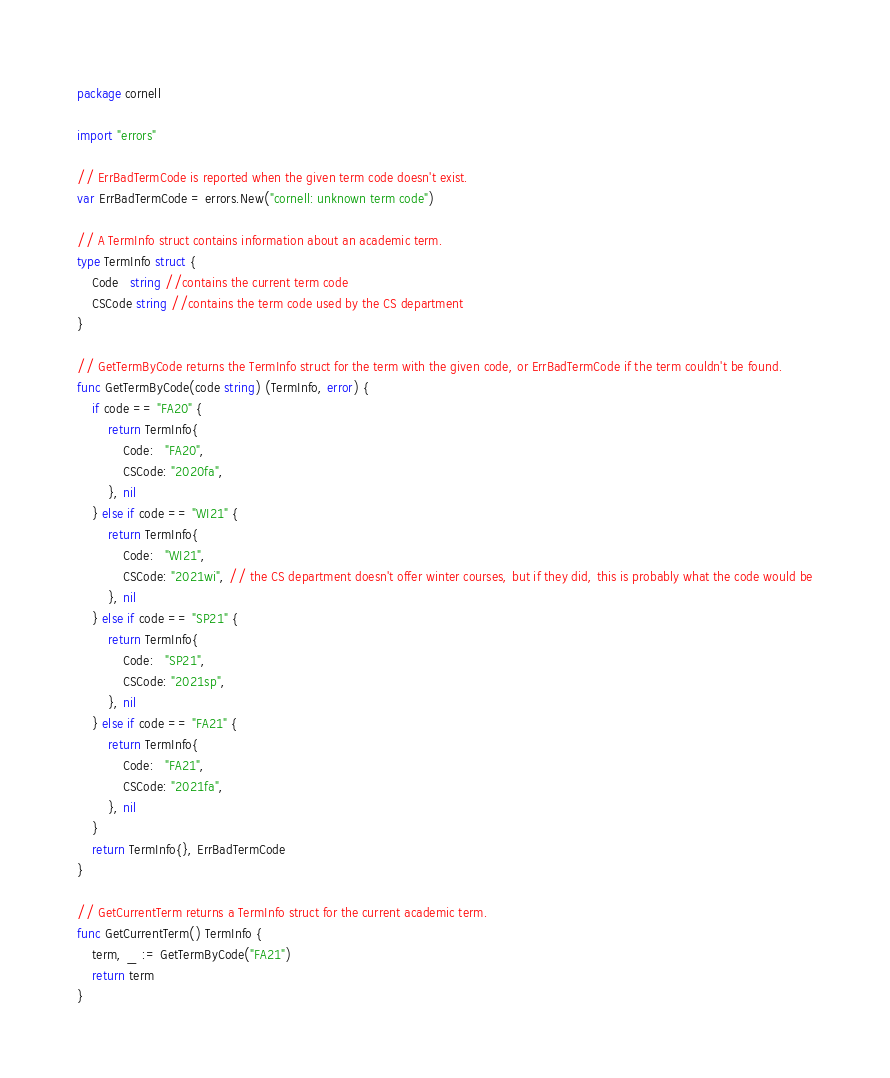<code> <loc_0><loc_0><loc_500><loc_500><_Go_>package cornell

import "errors"

// ErrBadTermCode is reported when the given term code doesn't exist.
var ErrBadTermCode = errors.New("cornell: unknown term code")

// A TermInfo struct contains information about an academic term.
type TermInfo struct {
	Code   string //contains the current term code
	CSCode string //contains the term code used by the CS department
}

// GetTermByCode returns the TermInfo struct for the term with the given code, or ErrBadTermCode if the term couldn't be found.
func GetTermByCode(code string) (TermInfo, error) {
	if code == "FA20" {
		return TermInfo{
			Code:   "FA20",
			CSCode: "2020fa",
		}, nil
	} else if code == "WI21" {
		return TermInfo{
			Code:   "WI21",
			CSCode: "2021wi", // the CS department doesn't offer winter courses, but if they did, this is probably what the code would be
		}, nil
	} else if code == "SP21" {
		return TermInfo{
			Code:   "SP21",
			CSCode: "2021sp",
		}, nil
	} else if code == "FA21" {
		return TermInfo{
			Code:   "FA21",
			CSCode: "2021fa",
		}, nil
	}
	return TermInfo{}, ErrBadTermCode
}

// GetCurrentTerm returns a TermInfo struct for the current academic term.
func GetCurrentTerm() TermInfo {
	term, _ := GetTermByCode("FA21")
	return term
}
</code> 